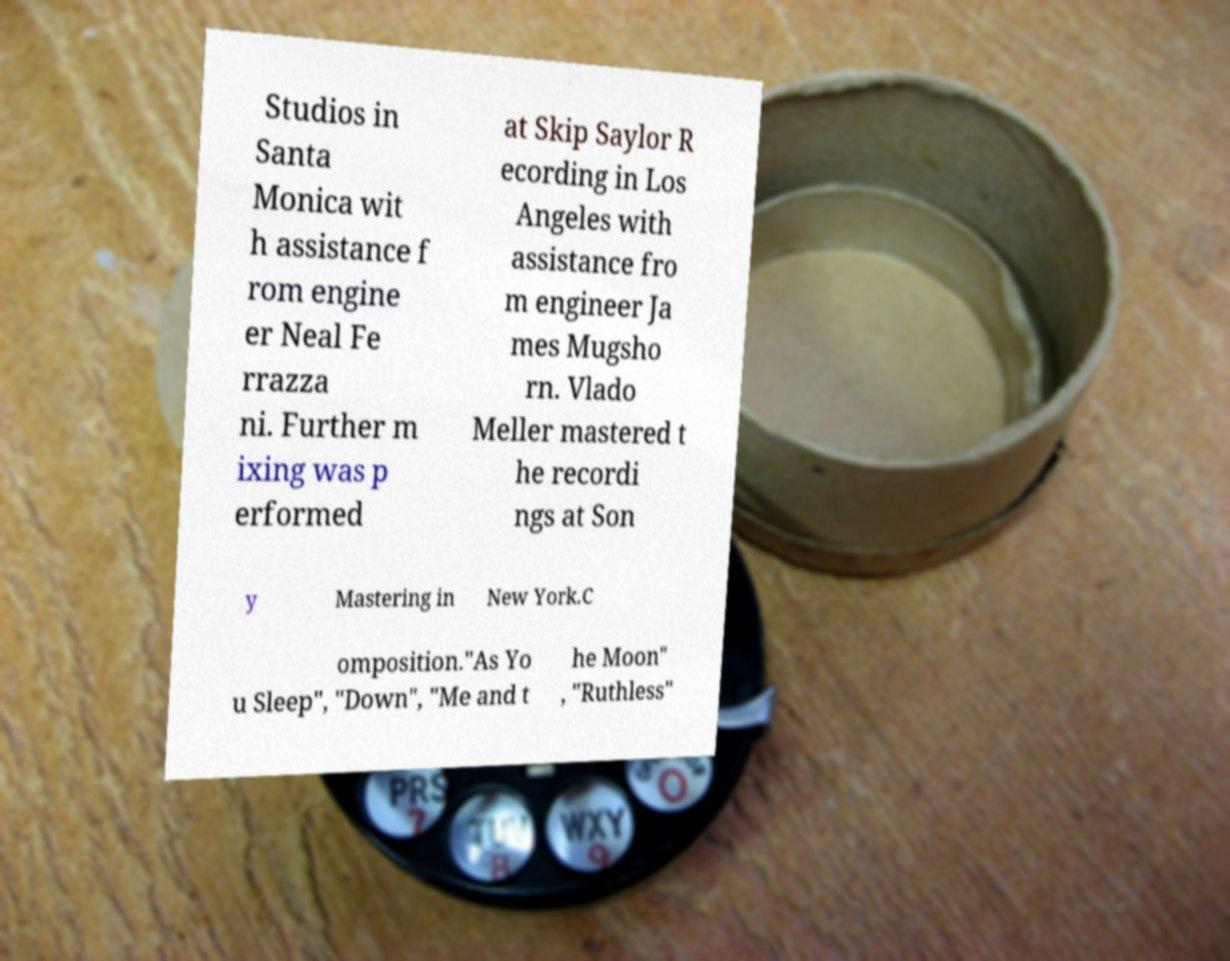Could you assist in decoding the text presented in this image and type it out clearly? Studios in Santa Monica wit h assistance f rom engine er Neal Fe rrazza ni. Further m ixing was p erformed at Skip Saylor R ecording in Los Angeles with assistance fro m engineer Ja mes Mugsho rn. Vlado Meller mastered t he recordi ngs at Son y Mastering in New York.C omposition."As Yo u Sleep", "Down", "Me and t he Moon" , "Ruthless" 